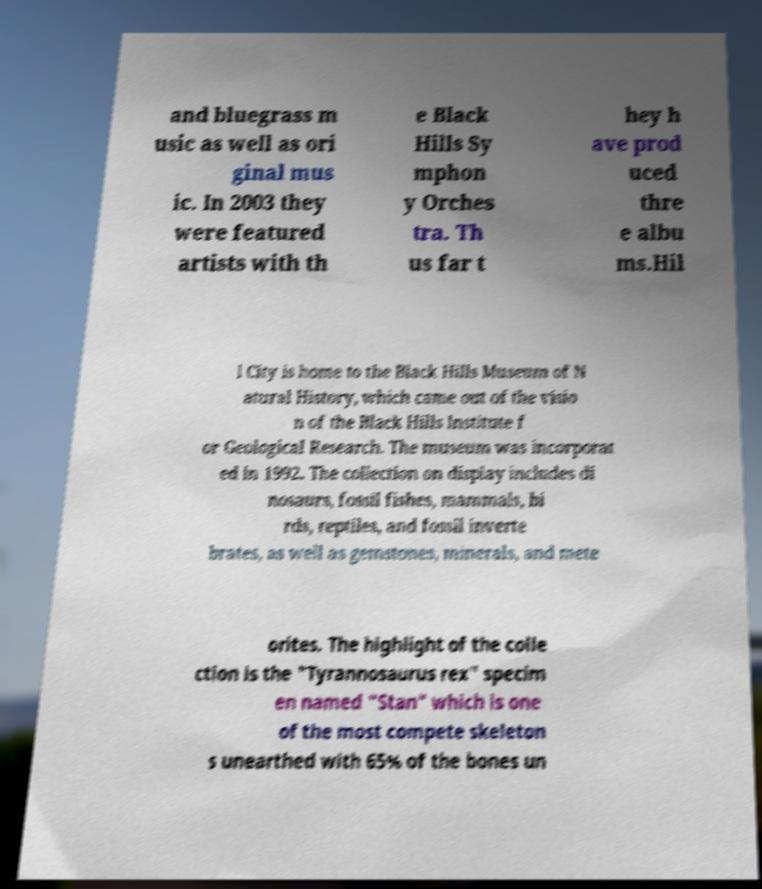What messages or text are displayed in this image? I need them in a readable, typed format. and bluegrass m usic as well as ori ginal mus ic. In 2003 they were featured artists with th e Black Hills Sy mphon y Orches tra. Th us far t hey h ave prod uced thre e albu ms.Hil l City is home to the Black Hills Museum of N atural History, which came out of the visio n of the Black Hills Institute f or Geological Research. The museum was incorporat ed in 1992. The collection on display includes di nosaurs, fossil fishes, mammals, bi rds, reptiles, and fossil inverte brates, as well as gemstones, minerals, and mete orites. The highlight of the colle ction is the "Tyrannosaurus rex" specim en named "Stan" which is one of the most compete skeleton s unearthed with 65% of the bones un 